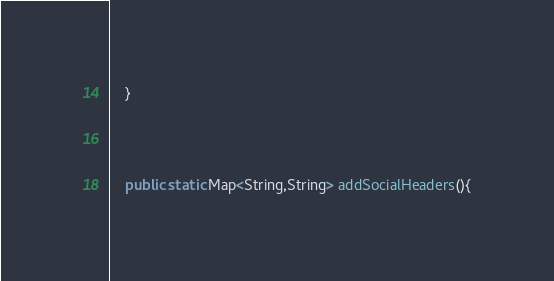<code> <loc_0><loc_0><loc_500><loc_500><_Java_>    }



    public static Map<String,String> addSocialHeaders(){</code> 